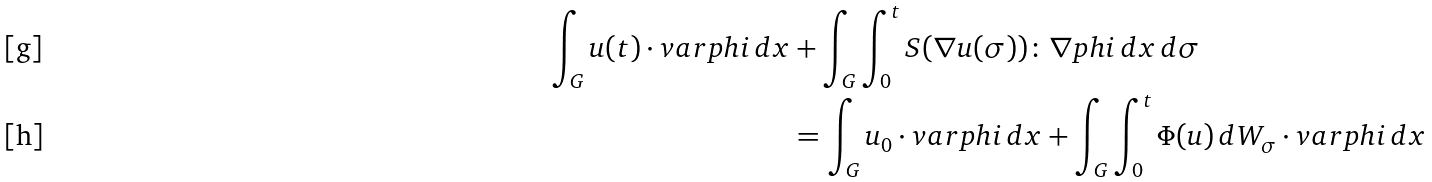<formula> <loc_0><loc_0><loc_500><loc_500>\int _ { G } u ( t ) \cdot v a r p h i \, d x & + \int _ { G } \int _ { 0 } ^ { t } S ( \nabla u ( \sigma ) ) \colon \nabla p h i \, d x \, d \sigma \\ & = \int _ { G } u _ { 0 } \cdot v a r p h i \, d x + \int _ { G } \int _ { 0 } ^ { t } \Phi ( u ) \, d W _ { \sigma } \cdot v a r p h i \, d x</formula> 